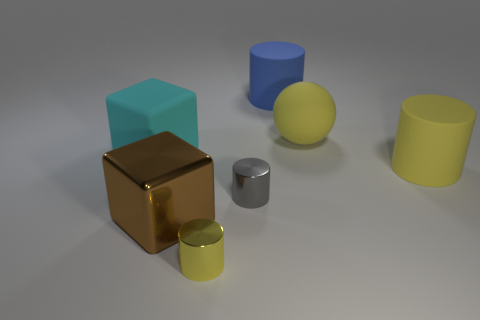There is a sphere; does it have the same color as the thing that is to the right of the matte sphere?
Your response must be concise. Yes. What material is the small yellow thing?
Offer a terse response. Metal. How many red objects are small metal objects or large spheres?
Ensure brevity in your answer.  0. What number of blue things are the same size as the cyan matte block?
Your answer should be very brief. 1. What shape is the rubber object that is the same color as the large rubber sphere?
Make the answer very short. Cylinder. How many objects are either cylinders or yellow objects on the right side of the yellow metallic object?
Ensure brevity in your answer.  5. Does the cube in front of the tiny gray metal cylinder have the same size as the metallic cylinder behind the large brown thing?
Offer a terse response. No. What number of other yellow matte objects are the same shape as the tiny yellow object?
Keep it short and to the point. 1. What is the shape of the yellow thing that is made of the same material as the large brown thing?
Your answer should be compact. Cylinder. What material is the small cylinder on the right side of the yellow cylinder left of the big cylinder behind the large yellow cylinder?
Your answer should be very brief. Metal. 